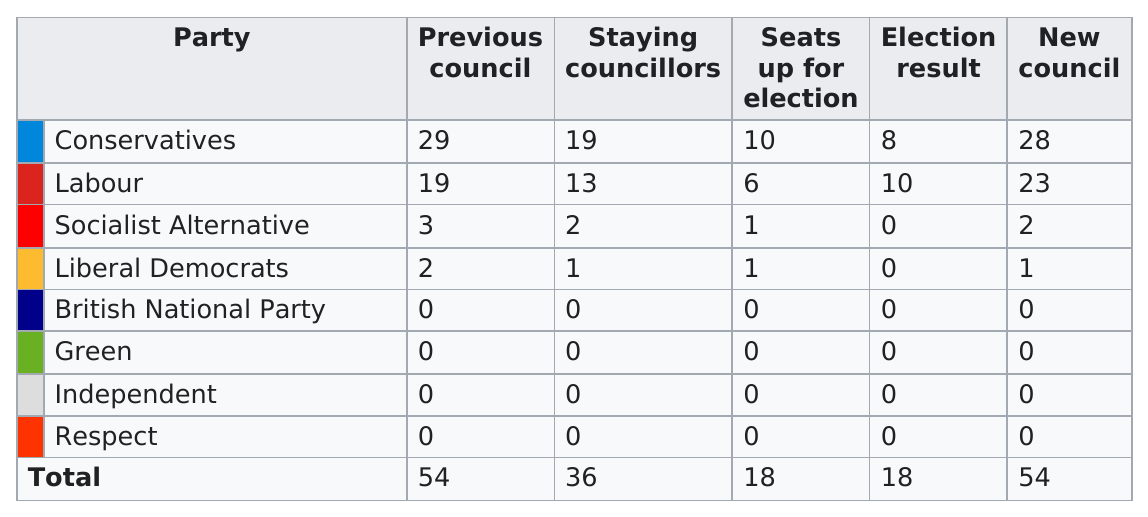List a handful of essential elements in this visual. Out of the 23 councillors who were staying, only 23 were not affiliated with the Labour Party. Out of the 4 parties, 0 councils were held by them. The category with the same total number as the election result, along with the number of seats up for election, will be the same. The Conservative party previously held the most council seats. The first party listed on this chart is Conservatives. 